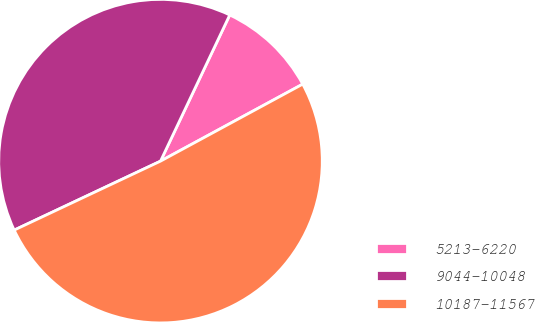Convert chart. <chart><loc_0><loc_0><loc_500><loc_500><pie_chart><fcel>5213-6220<fcel>9044-10048<fcel>10187-11567<nl><fcel>10.06%<fcel>39.05%<fcel>50.89%<nl></chart> 